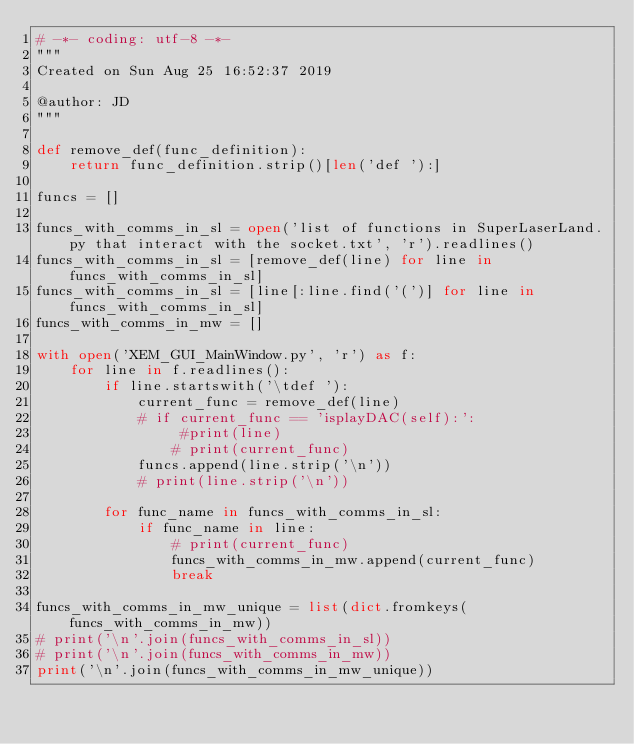Convert code to text. <code><loc_0><loc_0><loc_500><loc_500><_Python_># -*- coding: utf-8 -*-
"""
Created on Sun Aug 25 16:52:37 2019

@author: JD
"""

def remove_def(func_definition):
    return func_definition.strip()[len('def '):]

funcs = []

funcs_with_comms_in_sl = open('list of functions in SuperLaserLand.py that interact with the socket.txt', 'r').readlines()
funcs_with_comms_in_sl = [remove_def(line) for line in funcs_with_comms_in_sl]
funcs_with_comms_in_sl = [line[:line.find('(')] for line in funcs_with_comms_in_sl]
funcs_with_comms_in_mw = []

with open('XEM_GUI_MainWindow.py', 'r') as f:
    for line in f.readlines():
        if line.startswith('\tdef '):
            current_func = remove_def(line)
            # if current_func == 'isplayDAC(self):':
                 #print(line)
                # print(current_func)
            funcs.append(line.strip('\n'))
            # print(line.strip('\n'))
        
        for func_name in funcs_with_comms_in_sl:
            if func_name in line:
                # print(current_func)
                funcs_with_comms_in_mw.append(current_func)
                break

funcs_with_comms_in_mw_unique = list(dict.fromkeys(funcs_with_comms_in_mw))
# print('\n'.join(funcs_with_comms_in_sl))            
# print('\n'.join(funcs_with_comms_in_mw))
print('\n'.join(funcs_with_comms_in_mw_unique))
</code> 